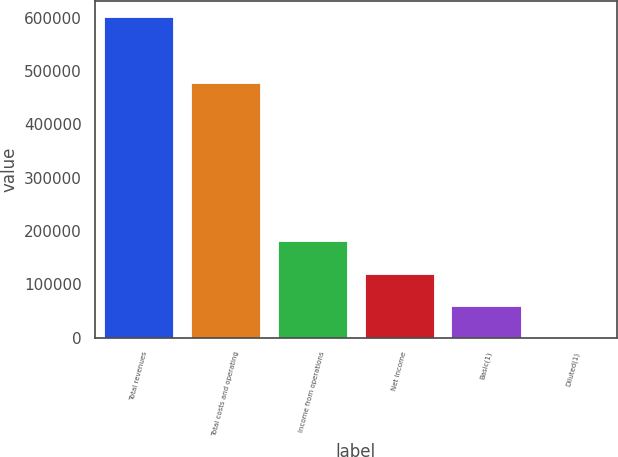<chart> <loc_0><loc_0><loc_500><loc_500><bar_chart><fcel>Total revenues<fcel>Total costs and operating<fcel>Income from operations<fcel>Net income<fcel>Basic(1)<fcel>Diluted(1)<nl><fcel>602219<fcel>477019<fcel>180666<fcel>120444<fcel>60222.4<fcel>0.61<nl></chart> 